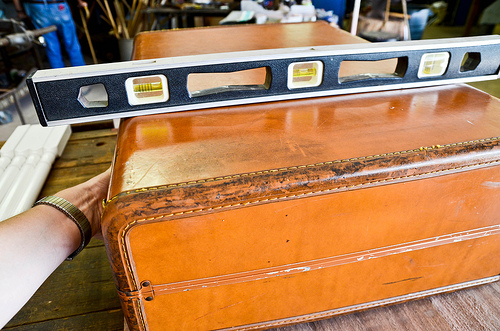<image>
Is there a level on the case? Yes. Looking at the image, I can see the level is positioned on top of the case, with the case providing support. 